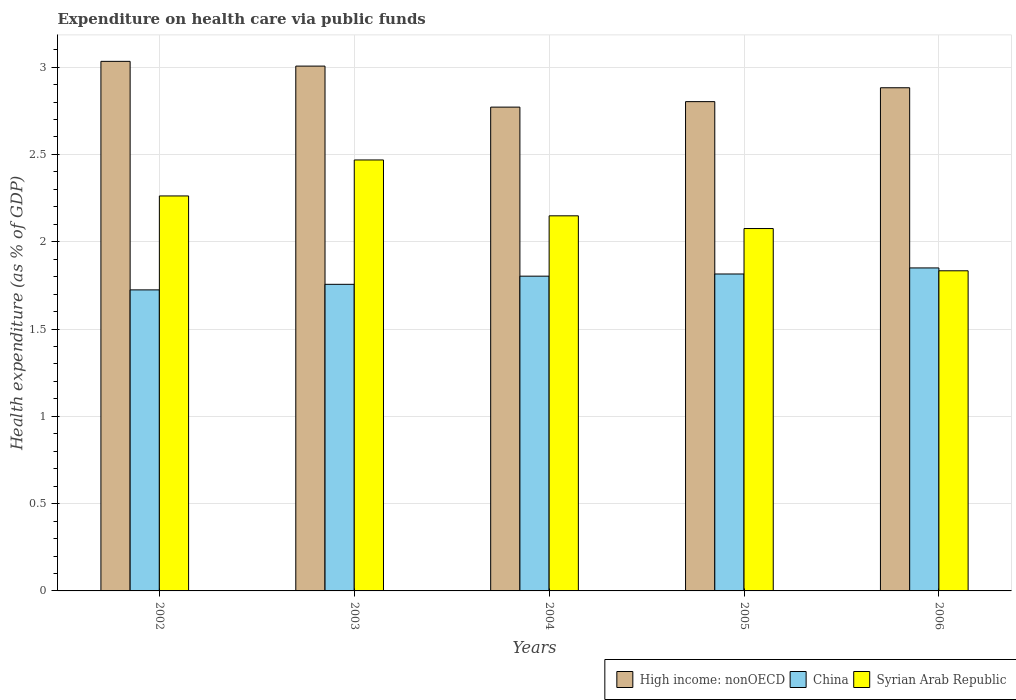How many groups of bars are there?
Ensure brevity in your answer.  5. Are the number of bars per tick equal to the number of legend labels?
Offer a terse response. Yes. How many bars are there on the 3rd tick from the right?
Provide a short and direct response. 3. What is the label of the 3rd group of bars from the left?
Keep it short and to the point. 2004. In how many cases, is the number of bars for a given year not equal to the number of legend labels?
Provide a short and direct response. 0. What is the expenditure made on health care in China in 2006?
Ensure brevity in your answer.  1.85. Across all years, what is the maximum expenditure made on health care in China?
Ensure brevity in your answer.  1.85. Across all years, what is the minimum expenditure made on health care in China?
Keep it short and to the point. 1.72. In which year was the expenditure made on health care in China maximum?
Make the answer very short. 2006. What is the total expenditure made on health care in High income: nonOECD in the graph?
Give a very brief answer. 14.49. What is the difference between the expenditure made on health care in Syrian Arab Republic in 2003 and that in 2005?
Offer a very short reply. 0.39. What is the difference between the expenditure made on health care in High income: nonOECD in 2005 and the expenditure made on health care in Syrian Arab Republic in 2002?
Ensure brevity in your answer.  0.54. What is the average expenditure made on health care in Syrian Arab Republic per year?
Offer a terse response. 2.16. In the year 2002, what is the difference between the expenditure made on health care in China and expenditure made on health care in Syrian Arab Republic?
Provide a succinct answer. -0.54. In how many years, is the expenditure made on health care in China greater than 0.6 %?
Your response must be concise. 5. What is the ratio of the expenditure made on health care in High income: nonOECD in 2002 to that in 2003?
Offer a very short reply. 1.01. Is the expenditure made on health care in High income: nonOECD in 2003 less than that in 2005?
Offer a very short reply. No. What is the difference between the highest and the second highest expenditure made on health care in Syrian Arab Republic?
Offer a very short reply. 0.21. What is the difference between the highest and the lowest expenditure made on health care in High income: nonOECD?
Provide a succinct answer. 0.26. In how many years, is the expenditure made on health care in High income: nonOECD greater than the average expenditure made on health care in High income: nonOECD taken over all years?
Ensure brevity in your answer.  2. What does the 2nd bar from the left in 2006 represents?
Make the answer very short. China. What does the 1st bar from the right in 2004 represents?
Offer a terse response. Syrian Arab Republic. Is it the case that in every year, the sum of the expenditure made on health care in Syrian Arab Republic and expenditure made on health care in High income: nonOECD is greater than the expenditure made on health care in China?
Offer a very short reply. Yes. How many bars are there?
Provide a succinct answer. 15. Are all the bars in the graph horizontal?
Your answer should be very brief. No. What is the difference between two consecutive major ticks on the Y-axis?
Provide a short and direct response. 0.5. Are the values on the major ticks of Y-axis written in scientific E-notation?
Provide a succinct answer. No. Does the graph contain grids?
Your response must be concise. Yes. What is the title of the graph?
Provide a short and direct response. Expenditure on health care via public funds. Does "Bhutan" appear as one of the legend labels in the graph?
Your answer should be very brief. No. What is the label or title of the Y-axis?
Your response must be concise. Health expenditure (as % of GDP). What is the Health expenditure (as % of GDP) in High income: nonOECD in 2002?
Provide a short and direct response. 3.03. What is the Health expenditure (as % of GDP) in China in 2002?
Keep it short and to the point. 1.72. What is the Health expenditure (as % of GDP) of Syrian Arab Republic in 2002?
Offer a very short reply. 2.26. What is the Health expenditure (as % of GDP) in High income: nonOECD in 2003?
Your answer should be very brief. 3.01. What is the Health expenditure (as % of GDP) of China in 2003?
Make the answer very short. 1.76. What is the Health expenditure (as % of GDP) of Syrian Arab Republic in 2003?
Make the answer very short. 2.47. What is the Health expenditure (as % of GDP) of High income: nonOECD in 2004?
Your response must be concise. 2.77. What is the Health expenditure (as % of GDP) of China in 2004?
Keep it short and to the point. 1.8. What is the Health expenditure (as % of GDP) in Syrian Arab Republic in 2004?
Your answer should be very brief. 2.15. What is the Health expenditure (as % of GDP) of High income: nonOECD in 2005?
Make the answer very short. 2.8. What is the Health expenditure (as % of GDP) of China in 2005?
Your answer should be compact. 1.82. What is the Health expenditure (as % of GDP) of Syrian Arab Republic in 2005?
Your answer should be compact. 2.08. What is the Health expenditure (as % of GDP) in High income: nonOECD in 2006?
Offer a very short reply. 2.88. What is the Health expenditure (as % of GDP) in China in 2006?
Keep it short and to the point. 1.85. What is the Health expenditure (as % of GDP) in Syrian Arab Republic in 2006?
Your answer should be compact. 1.83. Across all years, what is the maximum Health expenditure (as % of GDP) in High income: nonOECD?
Make the answer very short. 3.03. Across all years, what is the maximum Health expenditure (as % of GDP) of China?
Your answer should be very brief. 1.85. Across all years, what is the maximum Health expenditure (as % of GDP) in Syrian Arab Republic?
Keep it short and to the point. 2.47. Across all years, what is the minimum Health expenditure (as % of GDP) of High income: nonOECD?
Offer a very short reply. 2.77. Across all years, what is the minimum Health expenditure (as % of GDP) in China?
Provide a short and direct response. 1.72. Across all years, what is the minimum Health expenditure (as % of GDP) in Syrian Arab Republic?
Keep it short and to the point. 1.83. What is the total Health expenditure (as % of GDP) in High income: nonOECD in the graph?
Offer a terse response. 14.49. What is the total Health expenditure (as % of GDP) in China in the graph?
Your response must be concise. 8.95. What is the total Health expenditure (as % of GDP) of Syrian Arab Republic in the graph?
Provide a succinct answer. 10.79. What is the difference between the Health expenditure (as % of GDP) in High income: nonOECD in 2002 and that in 2003?
Provide a short and direct response. 0.03. What is the difference between the Health expenditure (as % of GDP) of China in 2002 and that in 2003?
Provide a short and direct response. -0.03. What is the difference between the Health expenditure (as % of GDP) in Syrian Arab Republic in 2002 and that in 2003?
Ensure brevity in your answer.  -0.21. What is the difference between the Health expenditure (as % of GDP) of High income: nonOECD in 2002 and that in 2004?
Your answer should be compact. 0.26. What is the difference between the Health expenditure (as % of GDP) of China in 2002 and that in 2004?
Ensure brevity in your answer.  -0.08. What is the difference between the Health expenditure (as % of GDP) of Syrian Arab Republic in 2002 and that in 2004?
Ensure brevity in your answer.  0.11. What is the difference between the Health expenditure (as % of GDP) in High income: nonOECD in 2002 and that in 2005?
Provide a succinct answer. 0.23. What is the difference between the Health expenditure (as % of GDP) in China in 2002 and that in 2005?
Give a very brief answer. -0.09. What is the difference between the Health expenditure (as % of GDP) of Syrian Arab Republic in 2002 and that in 2005?
Your answer should be very brief. 0.19. What is the difference between the Health expenditure (as % of GDP) of High income: nonOECD in 2002 and that in 2006?
Give a very brief answer. 0.15. What is the difference between the Health expenditure (as % of GDP) of China in 2002 and that in 2006?
Make the answer very short. -0.13. What is the difference between the Health expenditure (as % of GDP) of Syrian Arab Republic in 2002 and that in 2006?
Your answer should be very brief. 0.43. What is the difference between the Health expenditure (as % of GDP) of High income: nonOECD in 2003 and that in 2004?
Offer a terse response. 0.23. What is the difference between the Health expenditure (as % of GDP) of China in 2003 and that in 2004?
Ensure brevity in your answer.  -0.05. What is the difference between the Health expenditure (as % of GDP) of Syrian Arab Republic in 2003 and that in 2004?
Your answer should be compact. 0.32. What is the difference between the Health expenditure (as % of GDP) of High income: nonOECD in 2003 and that in 2005?
Offer a very short reply. 0.2. What is the difference between the Health expenditure (as % of GDP) of China in 2003 and that in 2005?
Provide a succinct answer. -0.06. What is the difference between the Health expenditure (as % of GDP) in Syrian Arab Republic in 2003 and that in 2005?
Keep it short and to the point. 0.39. What is the difference between the Health expenditure (as % of GDP) of High income: nonOECD in 2003 and that in 2006?
Your answer should be very brief. 0.12. What is the difference between the Health expenditure (as % of GDP) of China in 2003 and that in 2006?
Make the answer very short. -0.09. What is the difference between the Health expenditure (as % of GDP) in Syrian Arab Republic in 2003 and that in 2006?
Your response must be concise. 0.63. What is the difference between the Health expenditure (as % of GDP) of High income: nonOECD in 2004 and that in 2005?
Your response must be concise. -0.03. What is the difference between the Health expenditure (as % of GDP) of China in 2004 and that in 2005?
Your answer should be very brief. -0.01. What is the difference between the Health expenditure (as % of GDP) in Syrian Arab Republic in 2004 and that in 2005?
Your answer should be compact. 0.07. What is the difference between the Health expenditure (as % of GDP) of High income: nonOECD in 2004 and that in 2006?
Ensure brevity in your answer.  -0.11. What is the difference between the Health expenditure (as % of GDP) in China in 2004 and that in 2006?
Your response must be concise. -0.05. What is the difference between the Health expenditure (as % of GDP) of Syrian Arab Republic in 2004 and that in 2006?
Your answer should be compact. 0.31. What is the difference between the Health expenditure (as % of GDP) in High income: nonOECD in 2005 and that in 2006?
Offer a very short reply. -0.08. What is the difference between the Health expenditure (as % of GDP) of China in 2005 and that in 2006?
Keep it short and to the point. -0.03. What is the difference between the Health expenditure (as % of GDP) in Syrian Arab Republic in 2005 and that in 2006?
Offer a terse response. 0.24. What is the difference between the Health expenditure (as % of GDP) in High income: nonOECD in 2002 and the Health expenditure (as % of GDP) in China in 2003?
Give a very brief answer. 1.28. What is the difference between the Health expenditure (as % of GDP) of High income: nonOECD in 2002 and the Health expenditure (as % of GDP) of Syrian Arab Republic in 2003?
Offer a terse response. 0.56. What is the difference between the Health expenditure (as % of GDP) in China in 2002 and the Health expenditure (as % of GDP) in Syrian Arab Republic in 2003?
Offer a terse response. -0.74. What is the difference between the Health expenditure (as % of GDP) in High income: nonOECD in 2002 and the Health expenditure (as % of GDP) in China in 2004?
Your answer should be compact. 1.23. What is the difference between the Health expenditure (as % of GDP) of High income: nonOECD in 2002 and the Health expenditure (as % of GDP) of Syrian Arab Republic in 2004?
Offer a terse response. 0.88. What is the difference between the Health expenditure (as % of GDP) of China in 2002 and the Health expenditure (as % of GDP) of Syrian Arab Republic in 2004?
Your response must be concise. -0.42. What is the difference between the Health expenditure (as % of GDP) in High income: nonOECD in 2002 and the Health expenditure (as % of GDP) in China in 2005?
Keep it short and to the point. 1.22. What is the difference between the Health expenditure (as % of GDP) of High income: nonOECD in 2002 and the Health expenditure (as % of GDP) of Syrian Arab Republic in 2005?
Offer a terse response. 0.96. What is the difference between the Health expenditure (as % of GDP) of China in 2002 and the Health expenditure (as % of GDP) of Syrian Arab Republic in 2005?
Your answer should be compact. -0.35. What is the difference between the Health expenditure (as % of GDP) of High income: nonOECD in 2002 and the Health expenditure (as % of GDP) of China in 2006?
Provide a short and direct response. 1.18. What is the difference between the Health expenditure (as % of GDP) in High income: nonOECD in 2002 and the Health expenditure (as % of GDP) in Syrian Arab Republic in 2006?
Keep it short and to the point. 1.2. What is the difference between the Health expenditure (as % of GDP) in China in 2002 and the Health expenditure (as % of GDP) in Syrian Arab Republic in 2006?
Your response must be concise. -0.11. What is the difference between the Health expenditure (as % of GDP) of High income: nonOECD in 2003 and the Health expenditure (as % of GDP) of China in 2004?
Offer a terse response. 1.2. What is the difference between the Health expenditure (as % of GDP) in High income: nonOECD in 2003 and the Health expenditure (as % of GDP) in Syrian Arab Republic in 2004?
Your answer should be very brief. 0.86. What is the difference between the Health expenditure (as % of GDP) of China in 2003 and the Health expenditure (as % of GDP) of Syrian Arab Republic in 2004?
Your response must be concise. -0.39. What is the difference between the Health expenditure (as % of GDP) in High income: nonOECD in 2003 and the Health expenditure (as % of GDP) in China in 2005?
Keep it short and to the point. 1.19. What is the difference between the Health expenditure (as % of GDP) of High income: nonOECD in 2003 and the Health expenditure (as % of GDP) of Syrian Arab Republic in 2005?
Ensure brevity in your answer.  0.93. What is the difference between the Health expenditure (as % of GDP) of China in 2003 and the Health expenditure (as % of GDP) of Syrian Arab Republic in 2005?
Offer a terse response. -0.32. What is the difference between the Health expenditure (as % of GDP) in High income: nonOECD in 2003 and the Health expenditure (as % of GDP) in China in 2006?
Your answer should be very brief. 1.16. What is the difference between the Health expenditure (as % of GDP) in High income: nonOECD in 2003 and the Health expenditure (as % of GDP) in Syrian Arab Republic in 2006?
Your response must be concise. 1.17. What is the difference between the Health expenditure (as % of GDP) of China in 2003 and the Health expenditure (as % of GDP) of Syrian Arab Republic in 2006?
Ensure brevity in your answer.  -0.08. What is the difference between the Health expenditure (as % of GDP) in High income: nonOECD in 2004 and the Health expenditure (as % of GDP) in China in 2005?
Give a very brief answer. 0.96. What is the difference between the Health expenditure (as % of GDP) in High income: nonOECD in 2004 and the Health expenditure (as % of GDP) in Syrian Arab Republic in 2005?
Keep it short and to the point. 0.7. What is the difference between the Health expenditure (as % of GDP) of China in 2004 and the Health expenditure (as % of GDP) of Syrian Arab Republic in 2005?
Give a very brief answer. -0.27. What is the difference between the Health expenditure (as % of GDP) of High income: nonOECD in 2004 and the Health expenditure (as % of GDP) of China in 2006?
Give a very brief answer. 0.92. What is the difference between the Health expenditure (as % of GDP) in China in 2004 and the Health expenditure (as % of GDP) in Syrian Arab Republic in 2006?
Keep it short and to the point. -0.03. What is the difference between the Health expenditure (as % of GDP) in High income: nonOECD in 2005 and the Health expenditure (as % of GDP) in China in 2006?
Your response must be concise. 0.95. What is the difference between the Health expenditure (as % of GDP) in High income: nonOECD in 2005 and the Health expenditure (as % of GDP) in Syrian Arab Republic in 2006?
Ensure brevity in your answer.  0.97. What is the difference between the Health expenditure (as % of GDP) of China in 2005 and the Health expenditure (as % of GDP) of Syrian Arab Republic in 2006?
Your response must be concise. -0.02. What is the average Health expenditure (as % of GDP) in High income: nonOECD per year?
Provide a succinct answer. 2.9. What is the average Health expenditure (as % of GDP) in China per year?
Provide a succinct answer. 1.79. What is the average Health expenditure (as % of GDP) of Syrian Arab Republic per year?
Make the answer very short. 2.16. In the year 2002, what is the difference between the Health expenditure (as % of GDP) of High income: nonOECD and Health expenditure (as % of GDP) of China?
Provide a short and direct response. 1.31. In the year 2002, what is the difference between the Health expenditure (as % of GDP) in High income: nonOECD and Health expenditure (as % of GDP) in Syrian Arab Republic?
Your answer should be very brief. 0.77. In the year 2002, what is the difference between the Health expenditure (as % of GDP) in China and Health expenditure (as % of GDP) in Syrian Arab Republic?
Give a very brief answer. -0.54. In the year 2003, what is the difference between the Health expenditure (as % of GDP) in High income: nonOECD and Health expenditure (as % of GDP) in China?
Ensure brevity in your answer.  1.25. In the year 2003, what is the difference between the Health expenditure (as % of GDP) in High income: nonOECD and Health expenditure (as % of GDP) in Syrian Arab Republic?
Ensure brevity in your answer.  0.54. In the year 2003, what is the difference between the Health expenditure (as % of GDP) in China and Health expenditure (as % of GDP) in Syrian Arab Republic?
Provide a succinct answer. -0.71. In the year 2004, what is the difference between the Health expenditure (as % of GDP) in High income: nonOECD and Health expenditure (as % of GDP) in China?
Provide a short and direct response. 0.97. In the year 2004, what is the difference between the Health expenditure (as % of GDP) in High income: nonOECD and Health expenditure (as % of GDP) in Syrian Arab Republic?
Provide a short and direct response. 0.62. In the year 2004, what is the difference between the Health expenditure (as % of GDP) of China and Health expenditure (as % of GDP) of Syrian Arab Republic?
Your response must be concise. -0.35. In the year 2005, what is the difference between the Health expenditure (as % of GDP) of High income: nonOECD and Health expenditure (as % of GDP) of China?
Make the answer very short. 0.99. In the year 2005, what is the difference between the Health expenditure (as % of GDP) in High income: nonOECD and Health expenditure (as % of GDP) in Syrian Arab Republic?
Your answer should be very brief. 0.73. In the year 2005, what is the difference between the Health expenditure (as % of GDP) of China and Health expenditure (as % of GDP) of Syrian Arab Republic?
Your answer should be very brief. -0.26. In the year 2006, what is the difference between the Health expenditure (as % of GDP) in High income: nonOECD and Health expenditure (as % of GDP) in China?
Keep it short and to the point. 1.03. In the year 2006, what is the difference between the Health expenditure (as % of GDP) of High income: nonOECD and Health expenditure (as % of GDP) of Syrian Arab Republic?
Your answer should be compact. 1.05. In the year 2006, what is the difference between the Health expenditure (as % of GDP) in China and Health expenditure (as % of GDP) in Syrian Arab Republic?
Give a very brief answer. 0.02. What is the ratio of the Health expenditure (as % of GDP) in High income: nonOECD in 2002 to that in 2003?
Keep it short and to the point. 1.01. What is the ratio of the Health expenditure (as % of GDP) in China in 2002 to that in 2003?
Ensure brevity in your answer.  0.98. What is the ratio of the Health expenditure (as % of GDP) in Syrian Arab Republic in 2002 to that in 2003?
Provide a succinct answer. 0.92. What is the ratio of the Health expenditure (as % of GDP) of High income: nonOECD in 2002 to that in 2004?
Make the answer very short. 1.09. What is the ratio of the Health expenditure (as % of GDP) of China in 2002 to that in 2004?
Give a very brief answer. 0.96. What is the ratio of the Health expenditure (as % of GDP) of Syrian Arab Republic in 2002 to that in 2004?
Give a very brief answer. 1.05. What is the ratio of the Health expenditure (as % of GDP) of High income: nonOECD in 2002 to that in 2005?
Provide a succinct answer. 1.08. What is the ratio of the Health expenditure (as % of GDP) in China in 2002 to that in 2005?
Offer a terse response. 0.95. What is the ratio of the Health expenditure (as % of GDP) of Syrian Arab Republic in 2002 to that in 2005?
Make the answer very short. 1.09. What is the ratio of the Health expenditure (as % of GDP) in High income: nonOECD in 2002 to that in 2006?
Offer a terse response. 1.05. What is the ratio of the Health expenditure (as % of GDP) in China in 2002 to that in 2006?
Offer a terse response. 0.93. What is the ratio of the Health expenditure (as % of GDP) in Syrian Arab Republic in 2002 to that in 2006?
Offer a very short reply. 1.23. What is the ratio of the Health expenditure (as % of GDP) in High income: nonOECD in 2003 to that in 2004?
Keep it short and to the point. 1.08. What is the ratio of the Health expenditure (as % of GDP) of China in 2003 to that in 2004?
Offer a terse response. 0.97. What is the ratio of the Health expenditure (as % of GDP) in Syrian Arab Republic in 2003 to that in 2004?
Make the answer very short. 1.15. What is the ratio of the Health expenditure (as % of GDP) in High income: nonOECD in 2003 to that in 2005?
Ensure brevity in your answer.  1.07. What is the ratio of the Health expenditure (as % of GDP) of China in 2003 to that in 2005?
Give a very brief answer. 0.97. What is the ratio of the Health expenditure (as % of GDP) of Syrian Arab Republic in 2003 to that in 2005?
Keep it short and to the point. 1.19. What is the ratio of the Health expenditure (as % of GDP) of High income: nonOECD in 2003 to that in 2006?
Keep it short and to the point. 1.04. What is the ratio of the Health expenditure (as % of GDP) in China in 2003 to that in 2006?
Offer a very short reply. 0.95. What is the ratio of the Health expenditure (as % of GDP) in Syrian Arab Republic in 2003 to that in 2006?
Your answer should be compact. 1.35. What is the ratio of the Health expenditure (as % of GDP) in High income: nonOECD in 2004 to that in 2005?
Keep it short and to the point. 0.99. What is the ratio of the Health expenditure (as % of GDP) in China in 2004 to that in 2005?
Keep it short and to the point. 0.99. What is the ratio of the Health expenditure (as % of GDP) of Syrian Arab Republic in 2004 to that in 2005?
Offer a very short reply. 1.04. What is the ratio of the Health expenditure (as % of GDP) of High income: nonOECD in 2004 to that in 2006?
Keep it short and to the point. 0.96. What is the ratio of the Health expenditure (as % of GDP) in China in 2004 to that in 2006?
Your response must be concise. 0.97. What is the ratio of the Health expenditure (as % of GDP) of Syrian Arab Republic in 2004 to that in 2006?
Offer a very short reply. 1.17. What is the ratio of the Health expenditure (as % of GDP) of High income: nonOECD in 2005 to that in 2006?
Your response must be concise. 0.97. What is the ratio of the Health expenditure (as % of GDP) of China in 2005 to that in 2006?
Provide a short and direct response. 0.98. What is the ratio of the Health expenditure (as % of GDP) in Syrian Arab Republic in 2005 to that in 2006?
Offer a terse response. 1.13. What is the difference between the highest and the second highest Health expenditure (as % of GDP) in High income: nonOECD?
Your response must be concise. 0.03. What is the difference between the highest and the second highest Health expenditure (as % of GDP) in China?
Offer a very short reply. 0.03. What is the difference between the highest and the second highest Health expenditure (as % of GDP) of Syrian Arab Republic?
Offer a very short reply. 0.21. What is the difference between the highest and the lowest Health expenditure (as % of GDP) in High income: nonOECD?
Provide a short and direct response. 0.26. What is the difference between the highest and the lowest Health expenditure (as % of GDP) in China?
Provide a short and direct response. 0.13. What is the difference between the highest and the lowest Health expenditure (as % of GDP) of Syrian Arab Republic?
Provide a short and direct response. 0.63. 